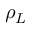Convert formula to latex. <formula><loc_0><loc_0><loc_500><loc_500>\rho _ { L }</formula> 